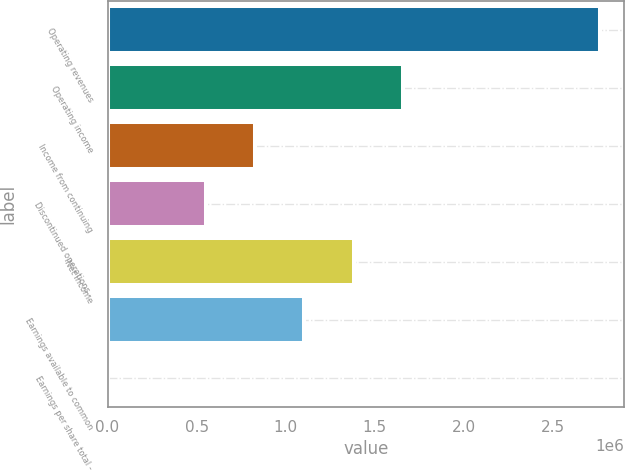<chart> <loc_0><loc_0><loc_500><loc_500><bar_chart><fcel>Operating revenues<fcel>Operating income<fcel>Income from continuing<fcel>Discontinued operations -<fcel>Net income<fcel>Earnings available to common<fcel>Earnings per share total -<nl><fcel>2.76366e+06<fcel>1.6582e+06<fcel>829099<fcel>552733<fcel>1.38183e+06<fcel>1.10546e+06<fcel>0.28<nl></chart> 